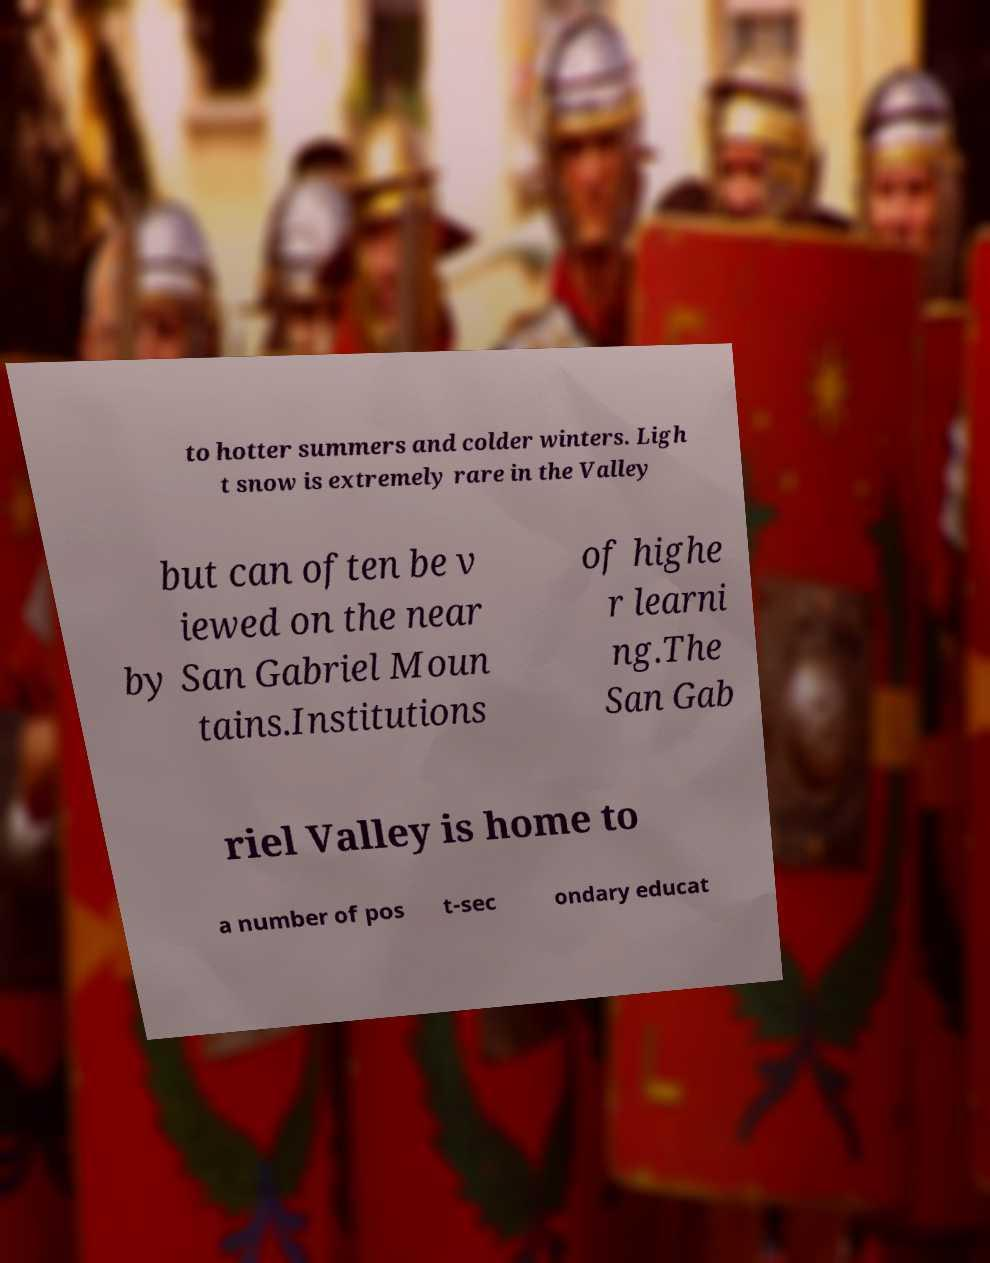Please identify and transcribe the text found in this image. to hotter summers and colder winters. Ligh t snow is extremely rare in the Valley but can often be v iewed on the near by San Gabriel Moun tains.Institutions of highe r learni ng.The San Gab riel Valley is home to a number of pos t-sec ondary educat 